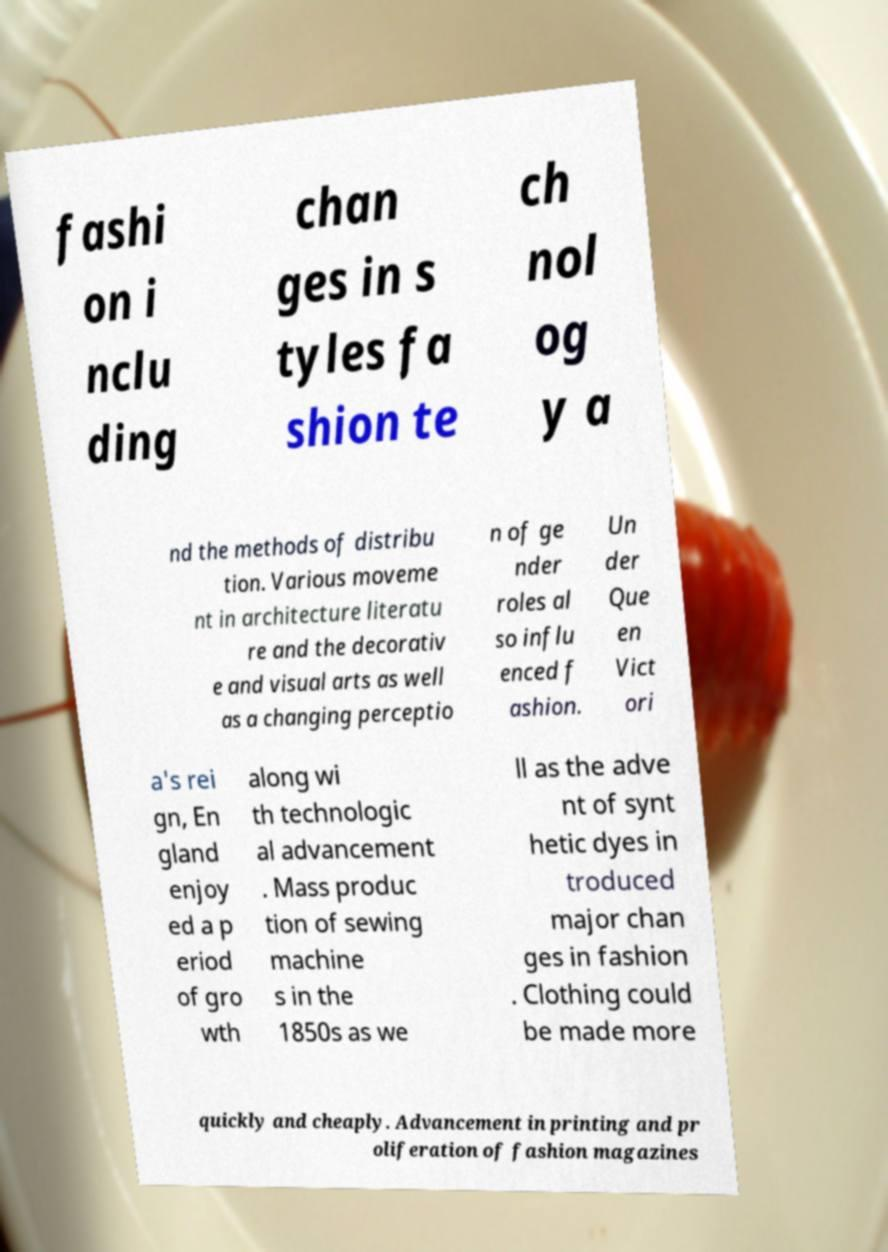Please read and relay the text visible in this image. What does it say? fashi on i nclu ding chan ges in s tyles fa shion te ch nol og y a nd the methods of distribu tion. Various moveme nt in architecture literatu re and the decorativ e and visual arts as well as a changing perceptio n of ge nder roles al so influ enced f ashion. Un der Que en Vict ori a's rei gn, En gland enjoy ed a p eriod of gro wth along wi th technologic al advancement . Mass produc tion of sewing machine s in the 1850s as we ll as the adve nt of synt hetic dyes in troduced major chan ges in fashion . Clothing could be made more quickly and cheaply. Advancement in printing and pr oliferation of fashion magazines 